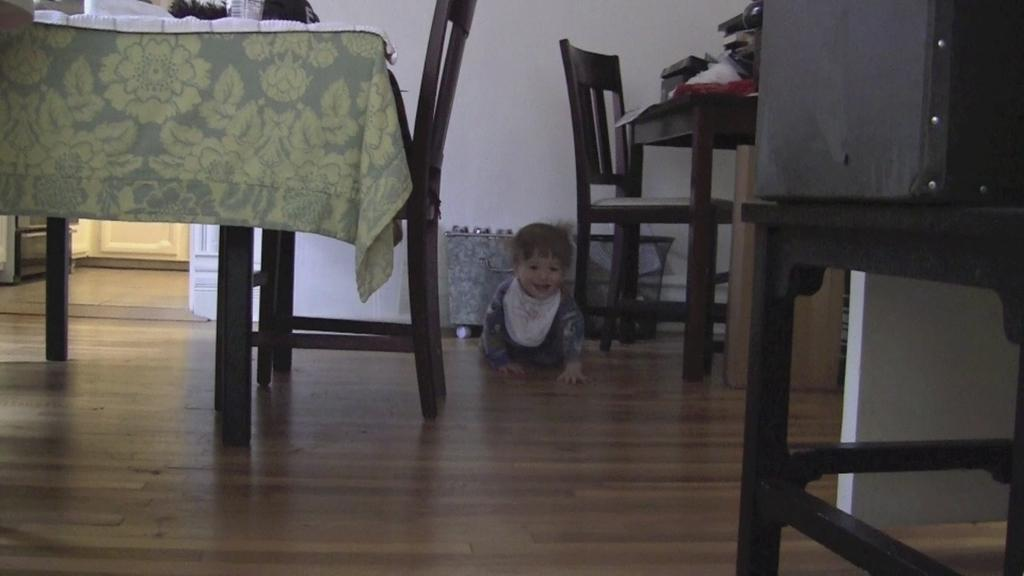What type of furniture is present in the image? There is a dining table in the image. What can be used to sit at the table? There are chairs in the image. Who is present at the table? There is a kid in the image. What is covering the table? There is a cloth on the table. What is placed on the table for drinking? There is a glass on the table. What object is present on the table that is not related to eating or drinking? There is a box on the table. How much dirt is visible on the floor in the image? There is no dirt visible on the floor in the image. What type of quilt is draped over the kid in the image? There is no quilt present in the image; the kid is not covered by any fabric. 